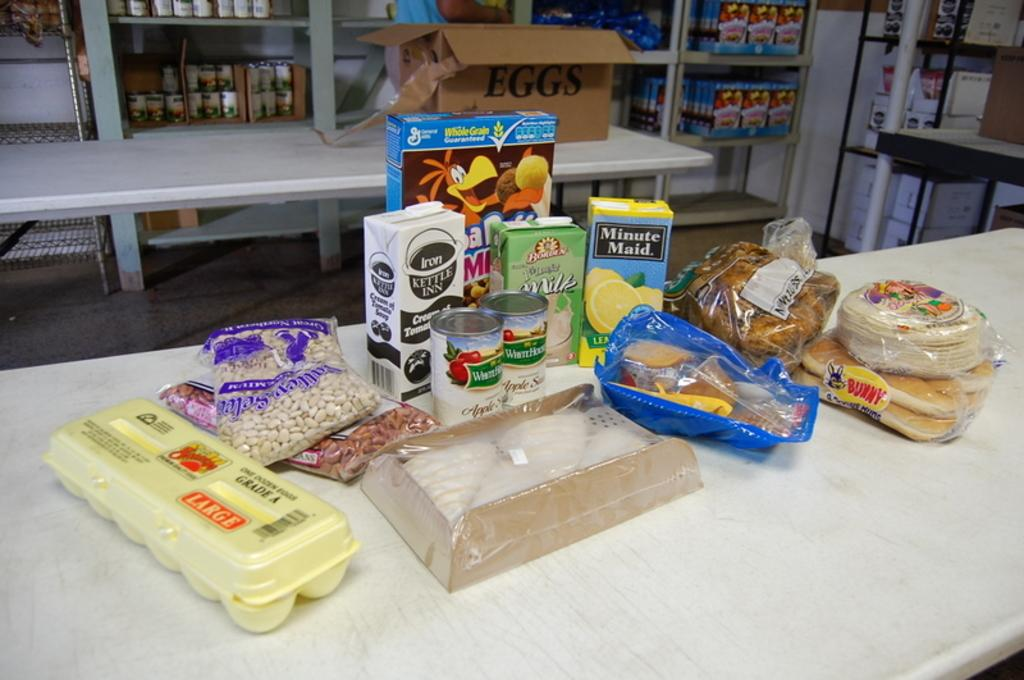What can be found on the tables in the image? There are food items and a box on the tables. Can you describe the contents of the box? The contents of the box cannot be determined from the image. What else can be seen in the background of the image? There are boxes and objects on the racks in the background. What color is the mass of the trick in the image? There is no mass or trick present in the image. 